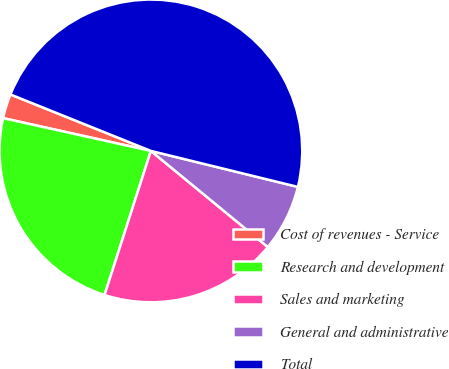<chart> <loc_0><loc_0><loc_500><loc_500><pie_chart><fcel>Cost of revenues - Service<fcel>Research and development<fcel>Sales and marketing<fcel>General and administrative<fcel>Total<nl><fcel>2.61%<fcel>23.52%<fcel>19.0%<fcel>7.13%<fcel>47.74%<nl></chart> 